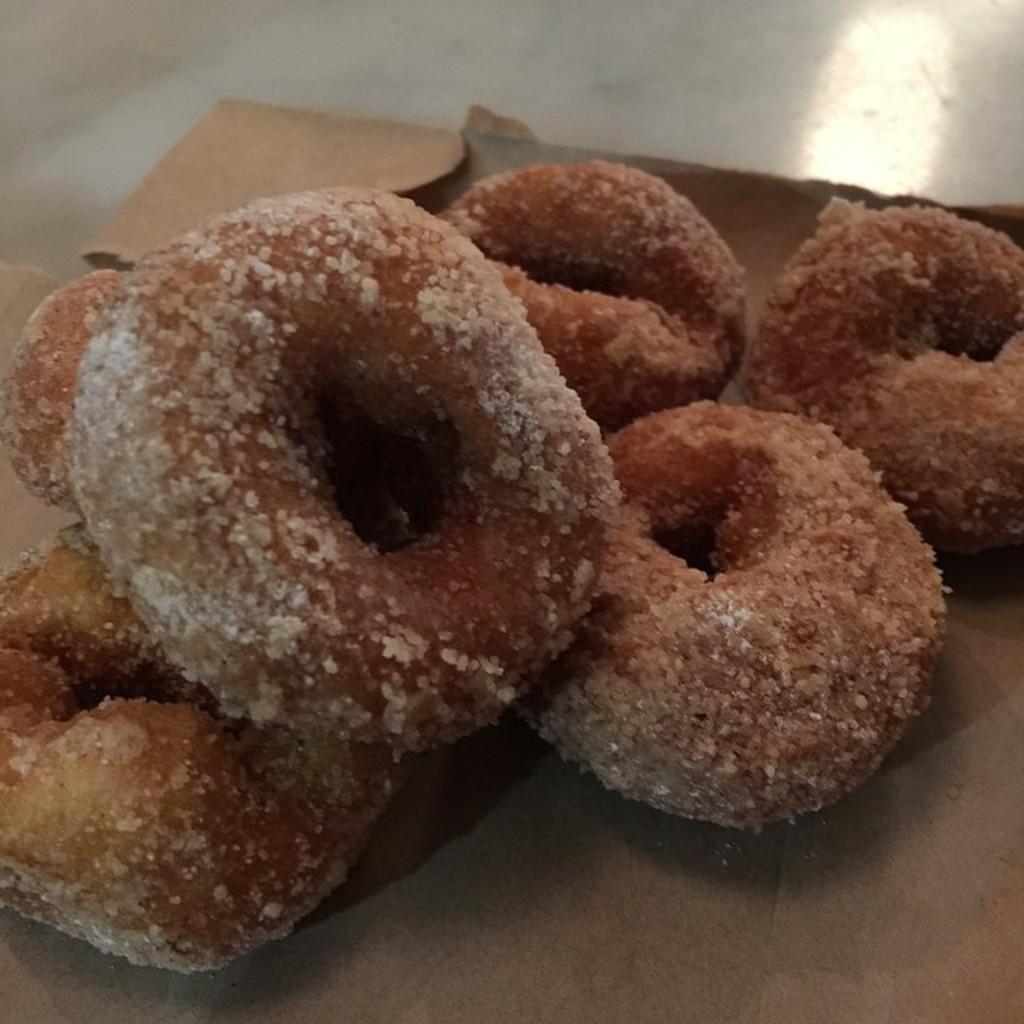Please provide a concise description of this image. In this picture we can observe some food placed on the box. The cardboard box is placed on the floor which is in white color. 